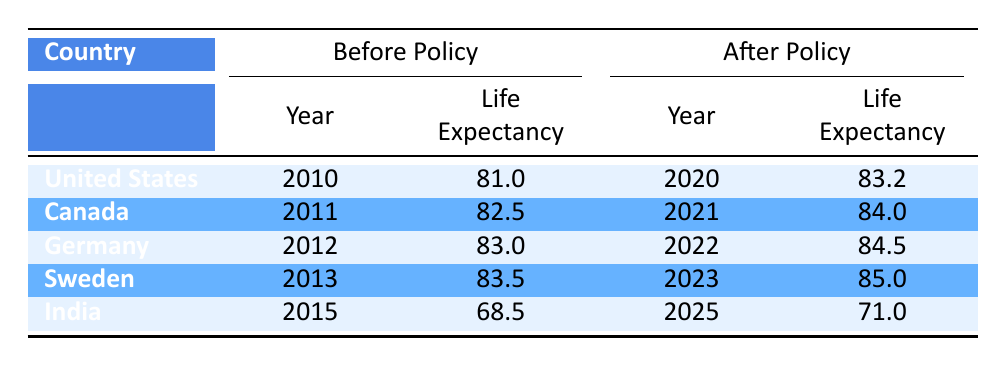What was the life expectancy of women in the United States before the implementation of the policy? In the row for the United States, the life expectancy before the policy is listed next to the year 2010, which shows a value of 81.0.
Answer: 81.0 What year was the women's health policy implemented in Canada? Looking at the Canada row, the year before the policy is 2011, indicating that the policy was implemented in 2011.
Answer: 2011 Which country had the lowest life expectancy for women before the policy? By examining each row, India had the lowest life expectancy before the policy at 68.5 compared to the other countries listed.
Answer: India What is the average life expectancy after the implementation of policies for the five countries listed? The life expectancies after the policy are 83.2, 84.0, 84.5, 85.0, and 71.0. Adding these values gives 408.0, and dividing by 5 results in an average of 81.6.
Answer: 81.6 Did Sweden see an increase in life expectancy for women after the policy was implemented? In the Sweden row, the life expectancy after the policy is 85.0, which is higher than the before policy life expectancy of 83.5, indicating an increase.
Answer: Yes How much did life expectancy increase for women in Germany after the policy? Subtract the life expectancy before the policy (83.0) from the life expectancy after the policy (84.5) in the Germany row. This gives an increase of 1.5 years.
Answer: 1.5 Which country experienced the largest increase in life expectancy after the implementation of women's health policies? By calculating the increases: United States (2.2), Canada (1.5), Germany (1.5), Sweden (1.5), and India (2.5). The largest increase is from India.
Answer: India Is it true that Canada had a life expectancy after the policy of more than 83 years? The life expectancy after the policy in Canada is 84.0, which is indeed more than 83 years.
Answer: Yes 